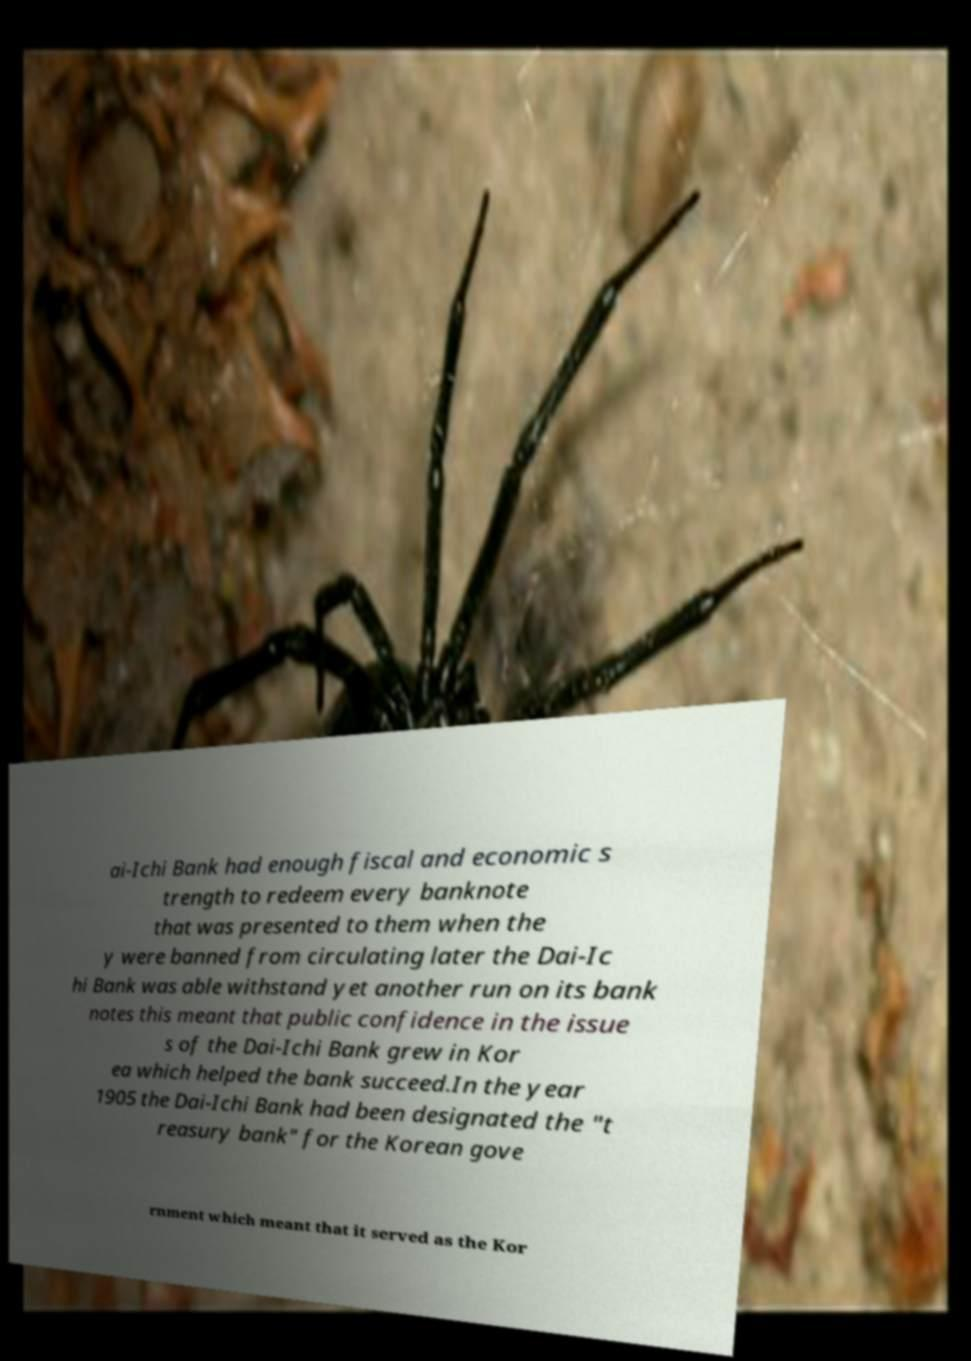For documentation purposes, I need the text within this image transcribed. Could you provide that? ai-Ichi Bank had enough fiscal and economic s trength to redeem every banknote that was presented to them when the y were banned from circulating later the Dai-Ic hi Bank was able withstand yet another run on its bank notes this meant that public confidence in the issue s of the Dai-Ichi Bank grew in Kor ea which helped the bank succeed.In the year 1905 the Dai-Ichi Bank had been designated the "t reasury bank" for the Korean gove rnment which meant that it served as the Kor 